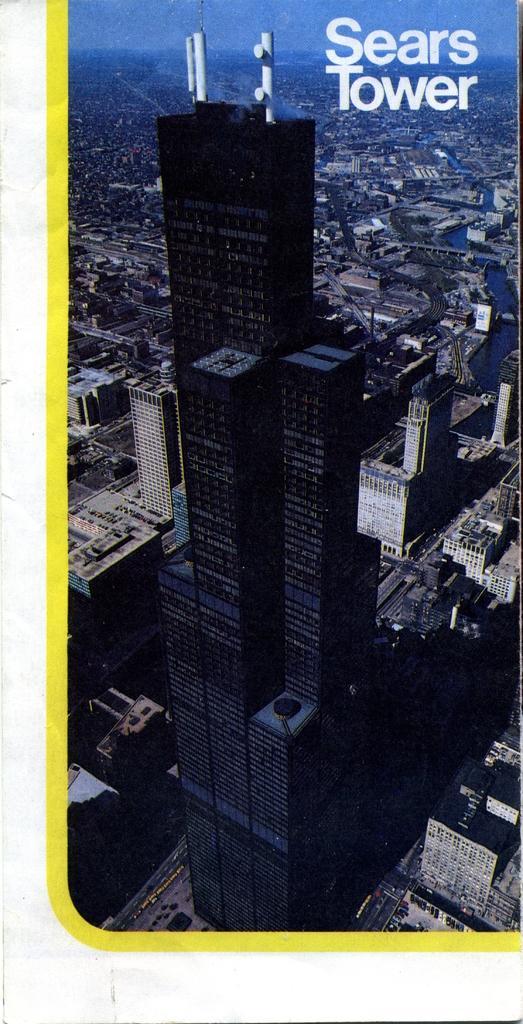Please provide a concise description of this image. In this image I can see buildings, roads and the sky. Here I can see a watermark on the image. 